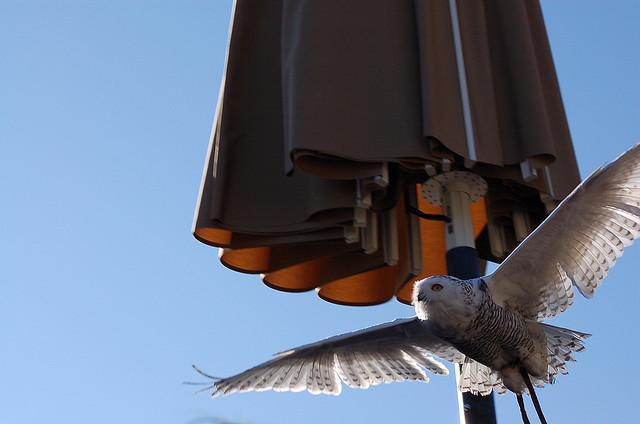How many umbrellas are in the photo?
Give a very brief answer. 1. How many people are in this picture?
Give a very brief answer. 0. 